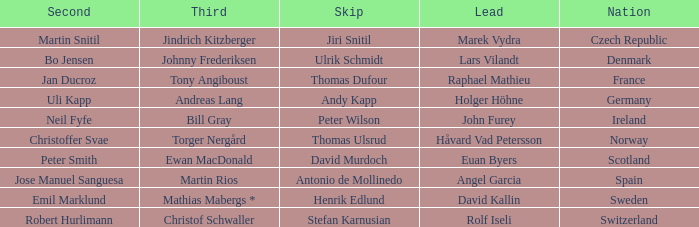When did France come in second? Jan Ducroz. 